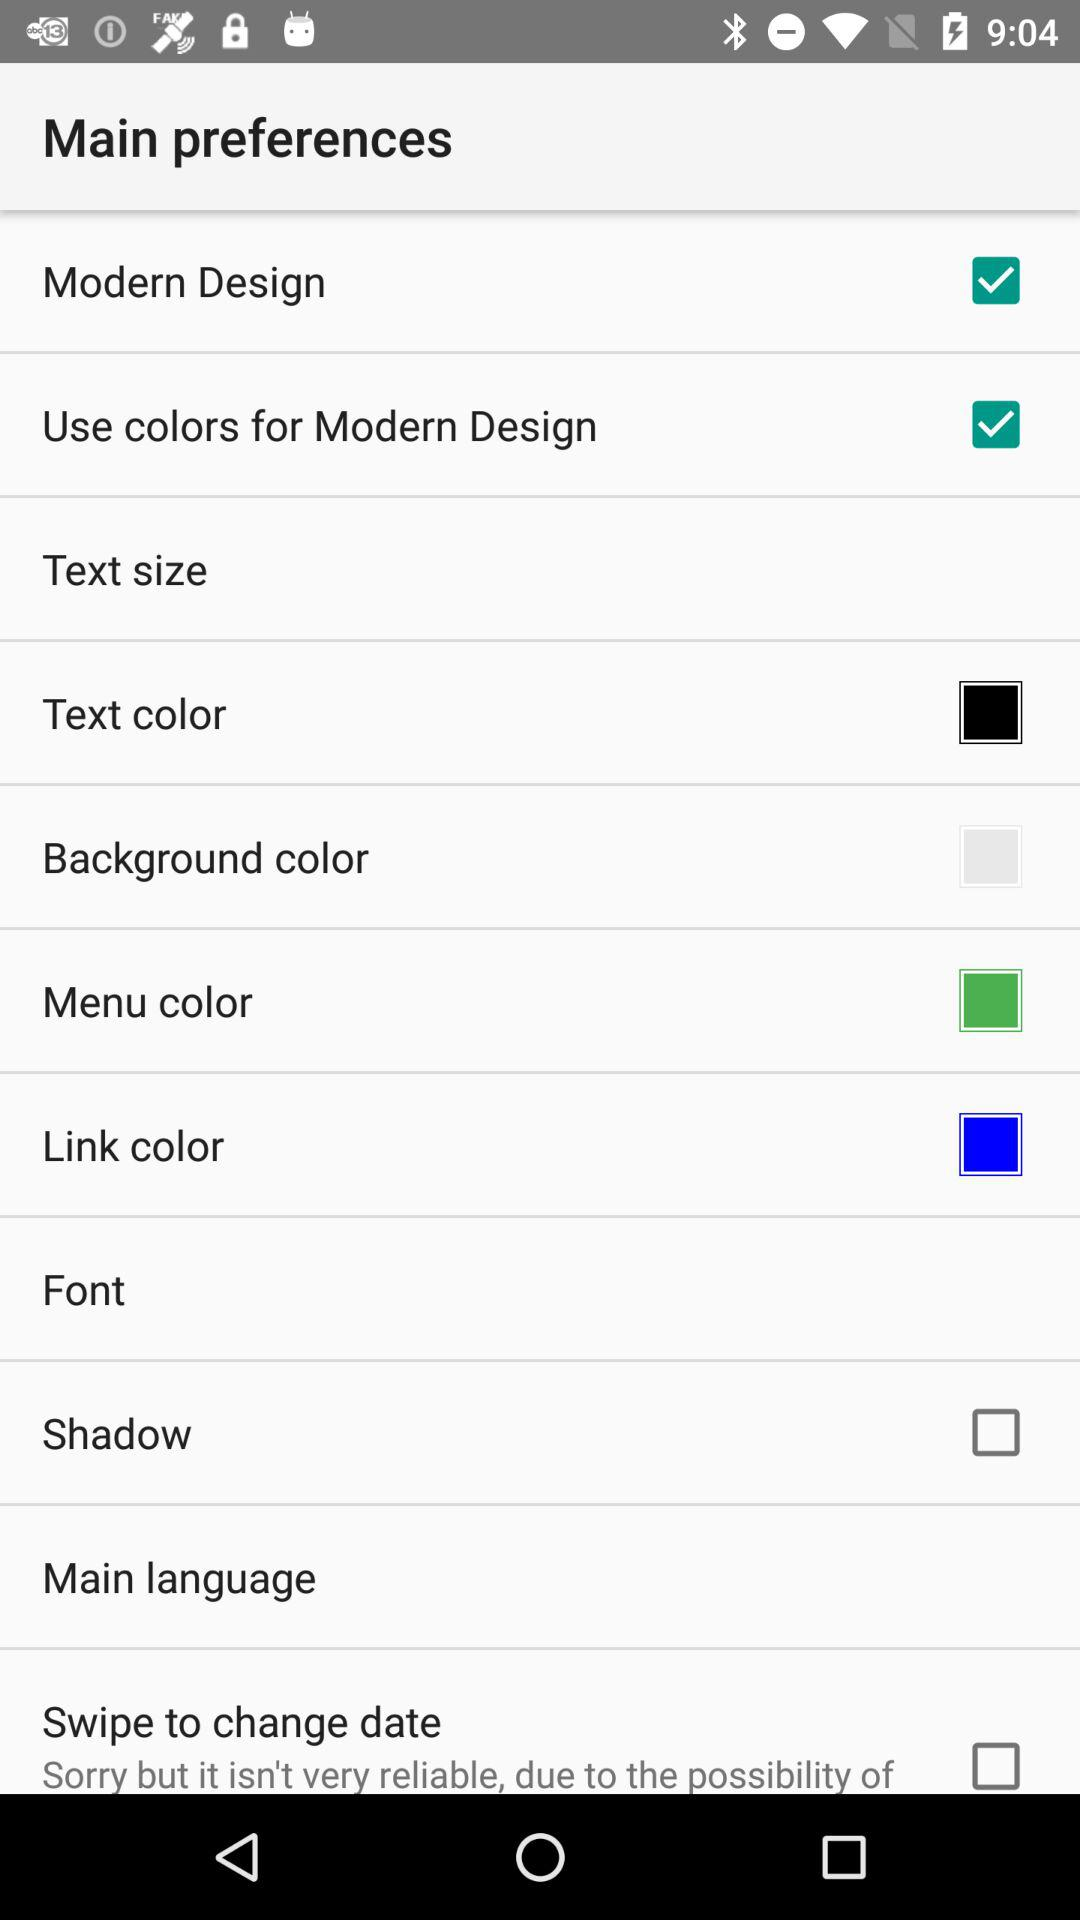What is the current status of the "Shadow"? The status is "off". 